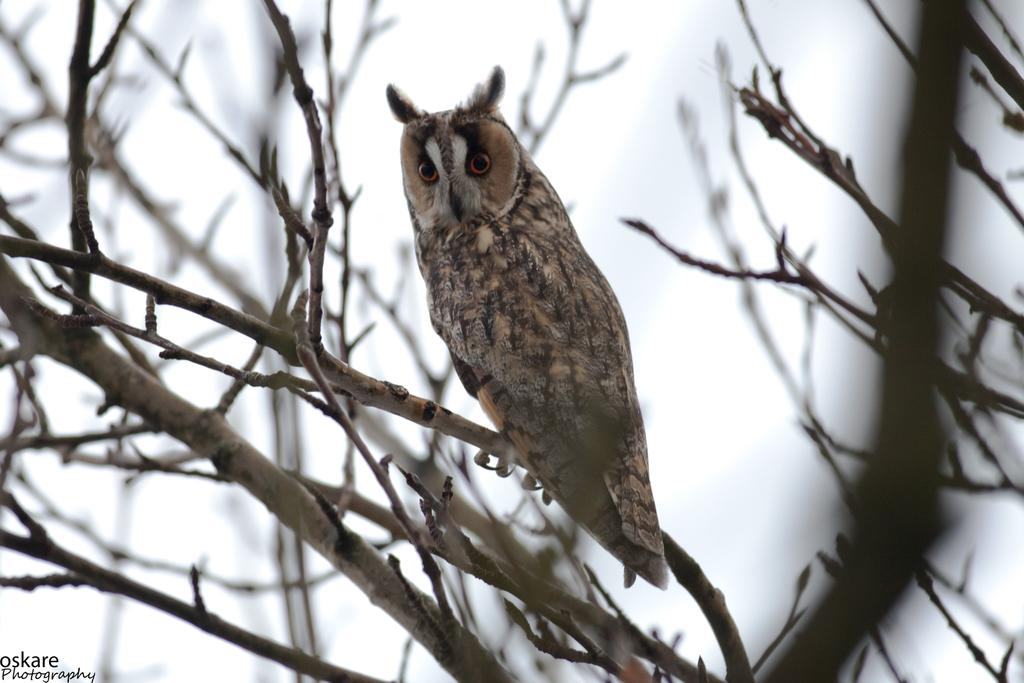What animal is in the image? There is an owl in the image. Where is the owl located? The owl is on a branch of a tree. What can be seen in the background of the image? There is a sky visible in the background of the image. Is there any text in the image? Yes, there is text in the left side bottom corner of the image. What is the price of the lake shown in the image? There is no lake present in the image, so it is not possible to determine its price. 